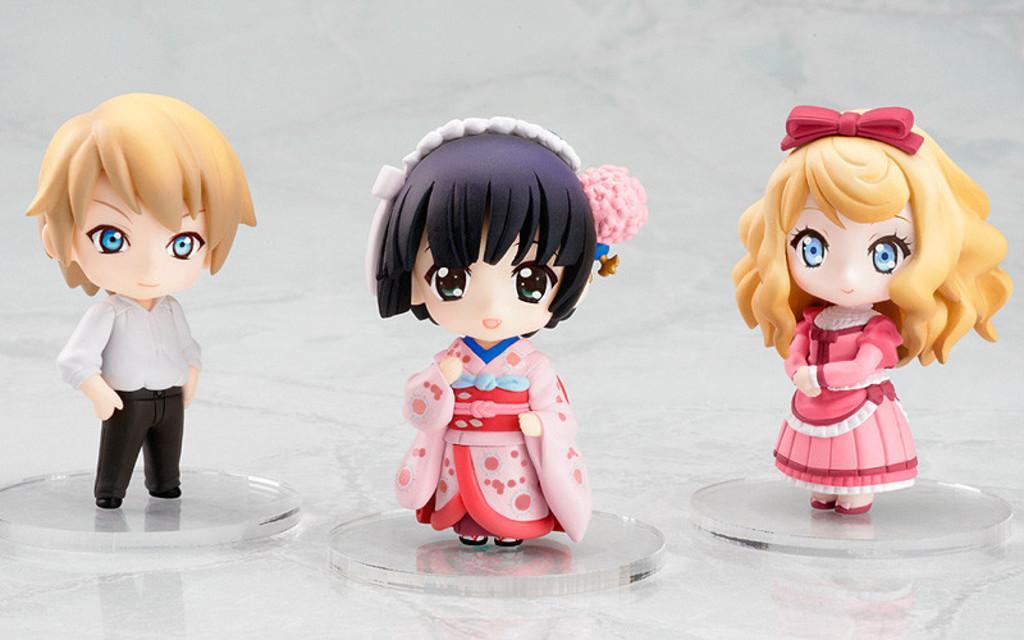In one or two sentences, can you explain what this image depicts? In this picture in the center there are toys. 